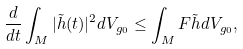<formula> <loc_0><loc_0><loc_500><loc_500>\frac { d } { d t } \int _ { M } | \tilde { h } ( t ) | ^ { 2 } d V _ { g _ { 0 } } \leq \int _ { M } F \tilde { h } d V _ { g _ { 0 } } ,</formula> 